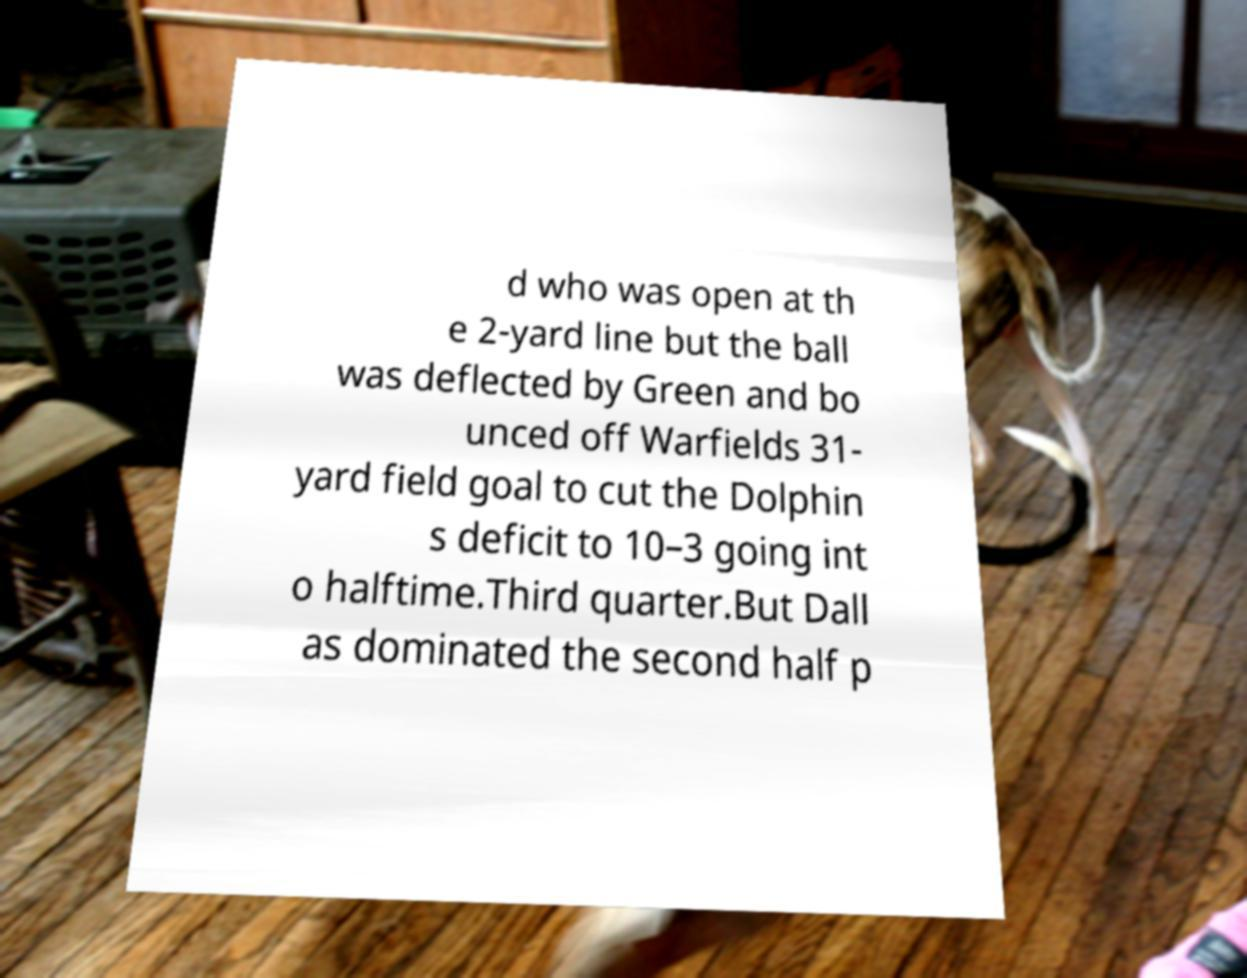Can you read and provide the text displayed in the image?This photo seems to have some interesting text. Can you extract and type it out for me? d who was open at th e 2-yard line but the ball was deflected by Green and bo unced off Warfields 31- yard field goal to cut the Dolphin s deficit to 10–3 going int o halftime.Third quarter.But Dall as dominated the second half p 